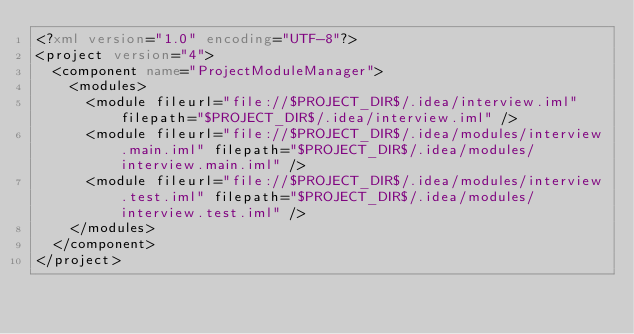Convert code to text. <code><loc_0><loc_0><loc_500><loc_500><_XML_><?xml version="1.0" encoding="UTF-8"?>
<project version="4">
  <component name="ProjectModuleManager">
    <modules>
      <module fileurl="file://$PROJECT_DIR$/.idea/interview.iml" filepath="$PROJECT_DIR$/.idea/interview.iml" />
      <module fileurl="file://$PROJECT_DIR$/.idea/modules/interview.main.iml" filepath="$PROJECT_DIR$/.idea/modules/interview.main.iml" />
      <module fileurl="file://$PROJECT_DIR$/.idea/modules/interview.test.iml" filepath="$PROJECT_DIR$/.idea/modules/interview.test.iml" />
    </modules>
  </component>
</project></code> 